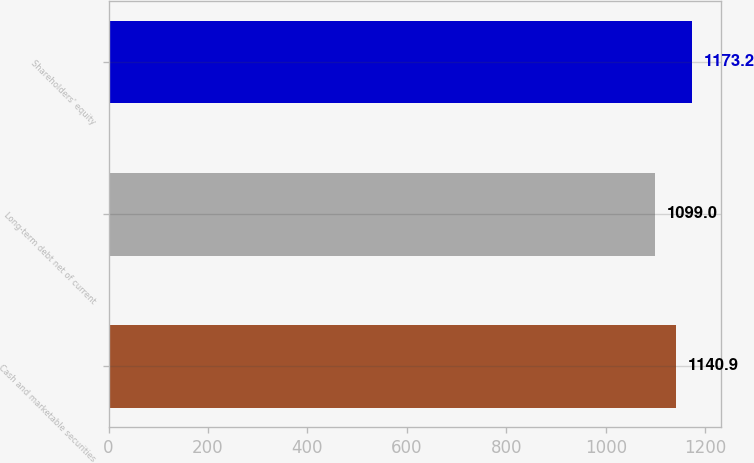Convert chart. <chart><loc_0><loc_0><loc_500><loc_500><bar_chart><fcel>Cash and marketable securities<fcel>Long-term debt net of current<fcel>Shareholders' equity<nl><fcel>1140.9<fcel>1099<fcel>1173.2<nl></chart> 